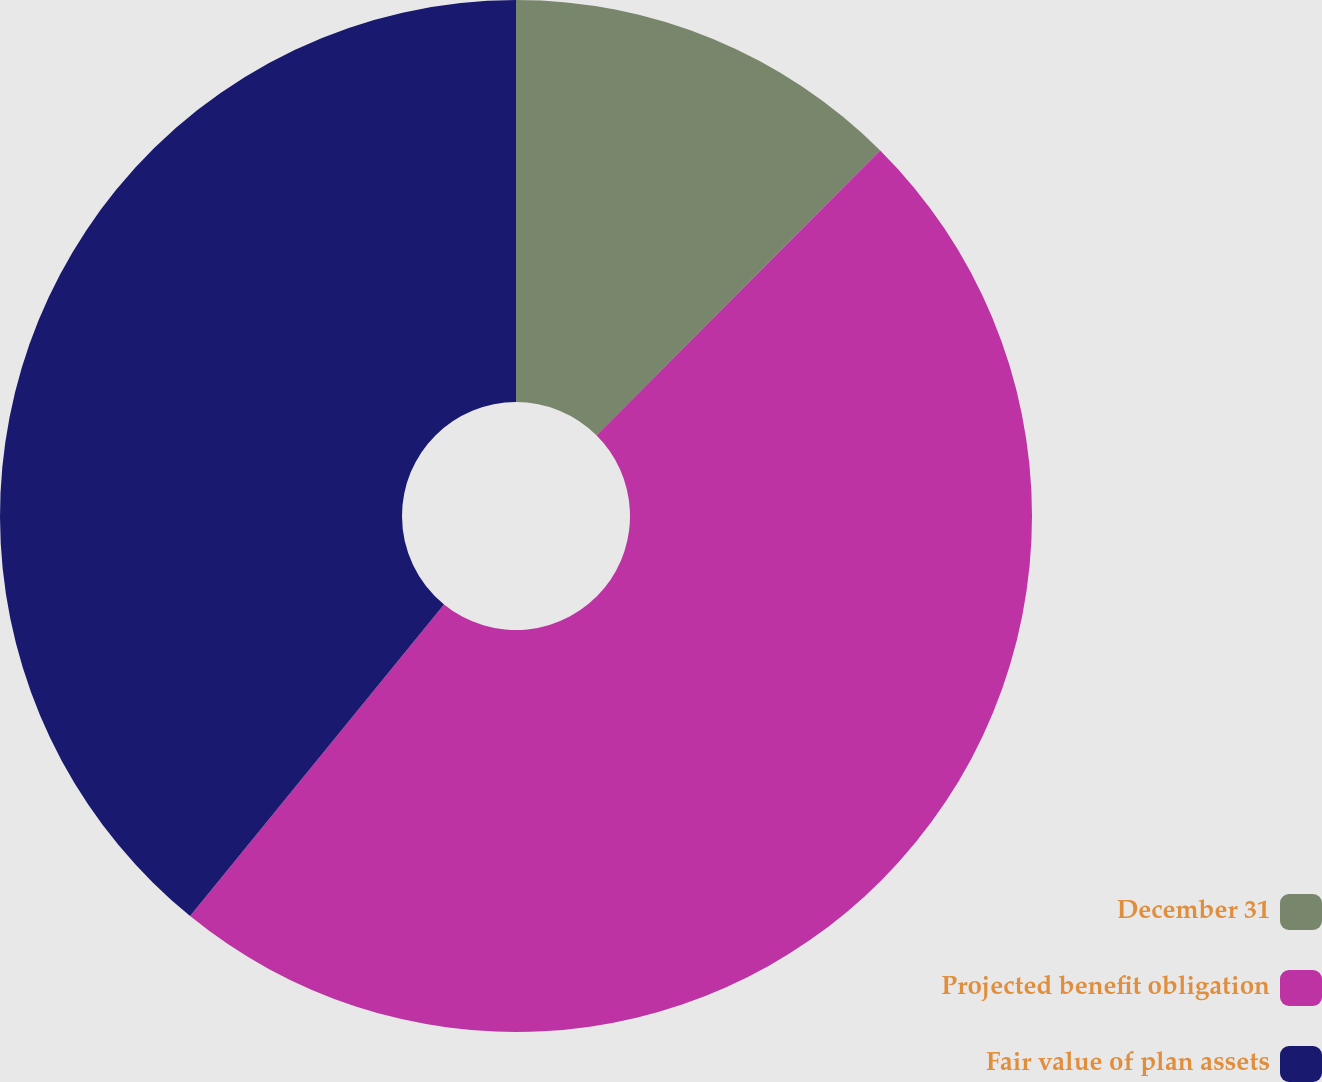<chart> <loc_0><loc_0><loc_500><loc_500><pie_chart><fcel>December 31<fcel>Projected benefit obligation<fcel>Fair value of plan assets<nl><fcel>12.47%<fcel>48.41%<fcel>39.12%<nl></chart> 